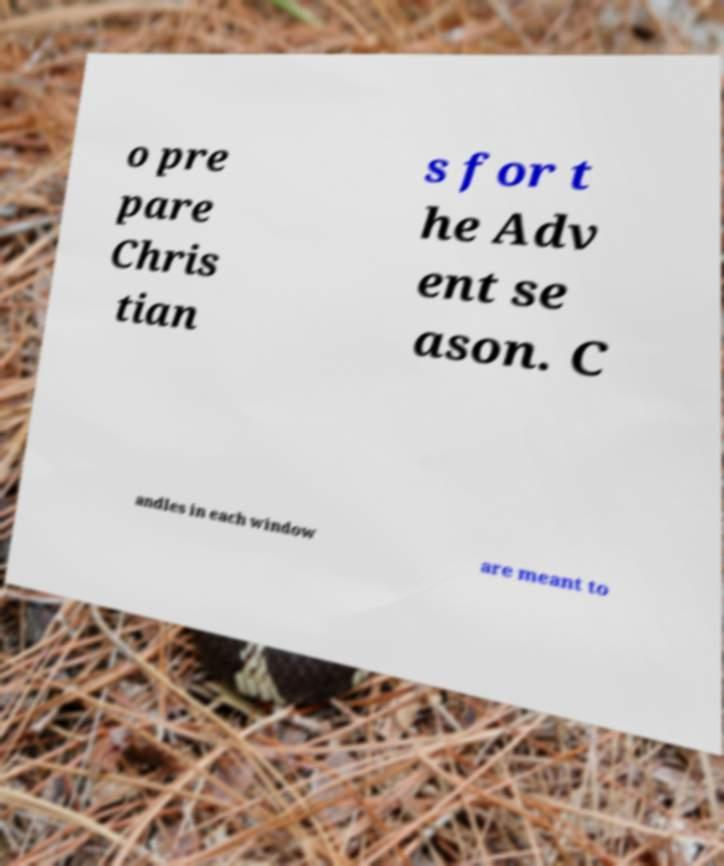Please read and relay the text visible in this image. What does it say? o pre pare Chris tian s for t he Adv ent se ason. C andles in each window are meant to 